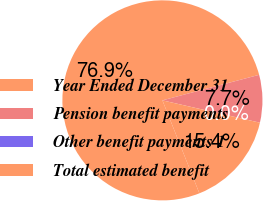Convert chart to OTSL. <chart><loc_0><loc_0><loc_500><loc_500><pie_chart><fcel>Year Ended December 31<fcel>Pension benefit payments<fcel>Other benefit payments 1<fcel>Total estimated benefit<nl><fcel>76.92%<fcel>7.69%<fcel>0.0%<fcel>15.39%<nl></chart> 